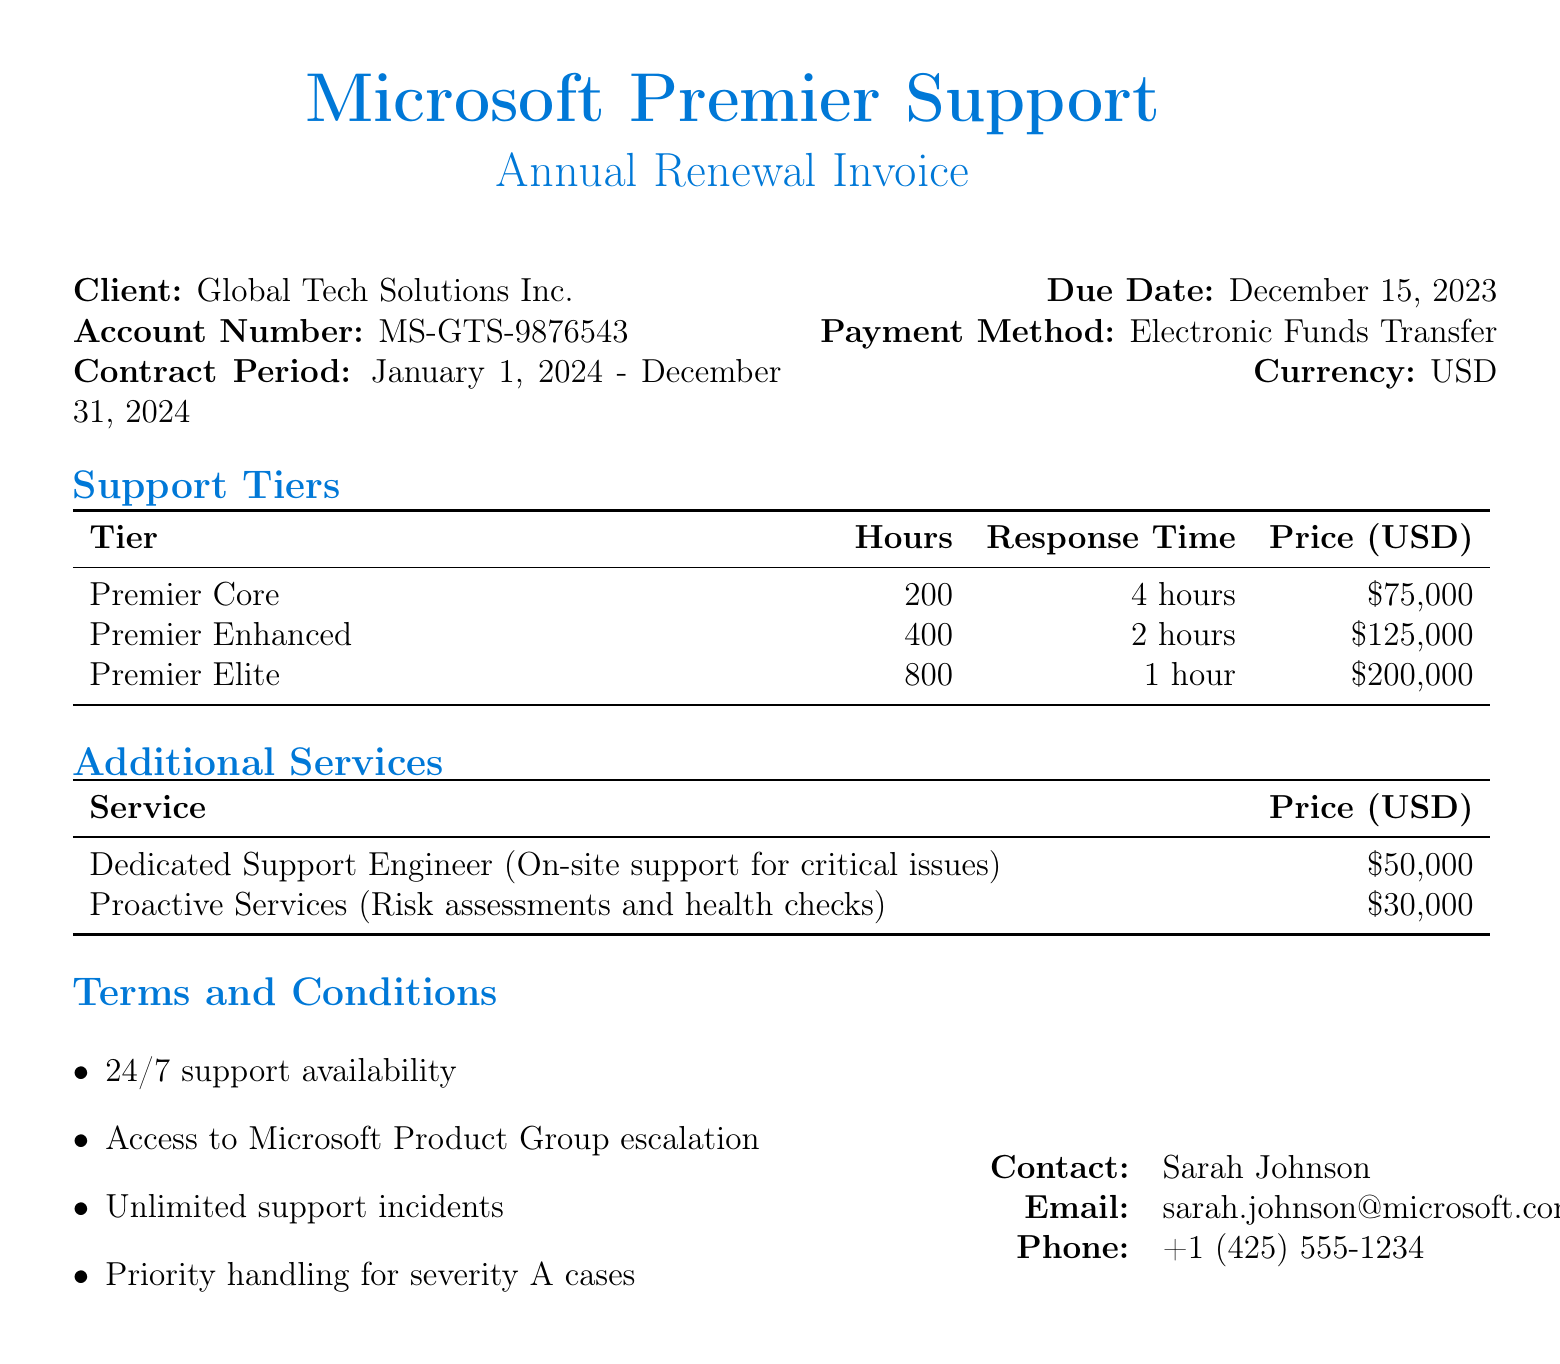what is the client name? The client name is found in the document under the Client section.
Answer: Global Tech Solutions Inc what is the account number? The account number is specified in the document.
Answer: MS-GTS-9876543 what is the contract period? The contract period is detailed in the document, indicating the start and end dates.
Answer: January 1, 2024 - December 31, 2024 what is the price of Premier Enhanced support? The price for Premier Enhanced support is listed in the Support Tiers table.
Answer: $125,000 what is the response time for Premier Elite support? The response time for Premier Elite support is provided in the Support Tiers table.
Answer: 1 hour which additional service costs $50,000? The additional services section lists services with their respective prices.
Answer: Dedicated Support Engineer (On-site support for critical issues) how many hours are included in the Premier Core tier? The number of hours is listed in the Support Tiers table for each tier.
Answer: 200 what is the due date for the payment? The due date is specified in the document.
Answer: December 15, 2023 who is the contact person for this invoice? The contact person is indicated in the contact information section.
Answer: Sarah Johnson 